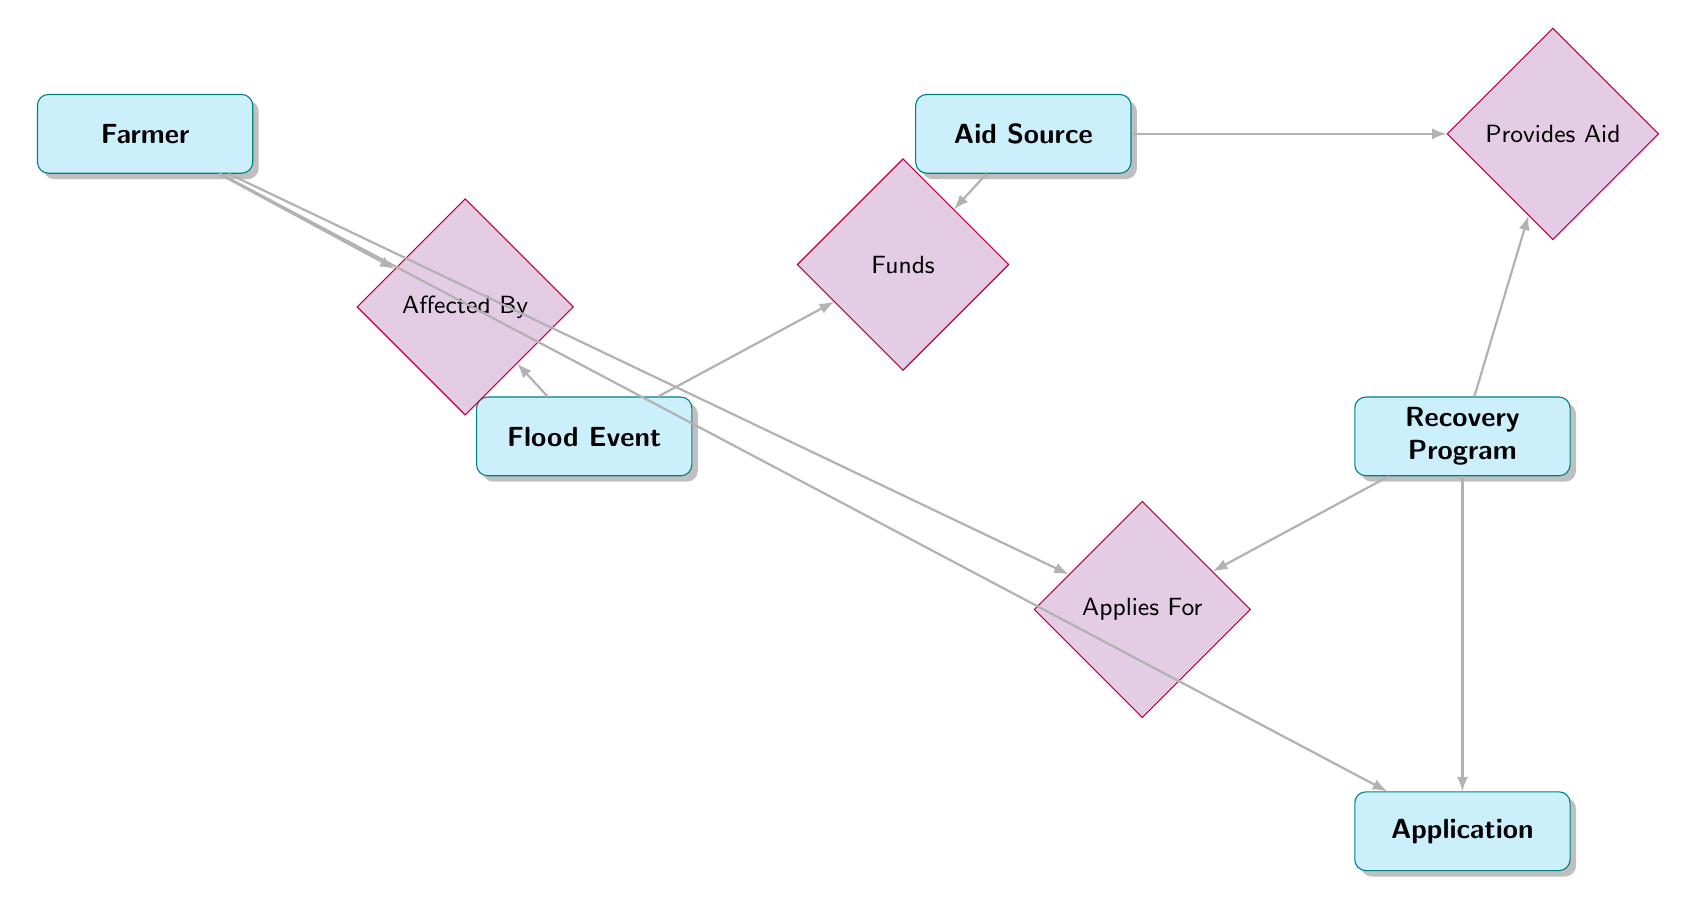What entities are present in the diagram? The diagram includes five entities: Farmer, Flood Event, Aid Source, Recovery Program, and Application.
Answer: Farmer, Flood Event, Aid Source, Recovery Program, Application How many relationships are shown in the diagram? There are four relationships in the diagram: Affected By, Provides Aid, Applies For, and Funds.
Answer: 4 What is the relationship between Farmer and Flood Event? The relationship is named Affected By, which indicates that Farmers are affected by Flood Events.
Answer: Affected By Which entity provides the aid for Recovery Programs? The Aid Source entity provides aid for Recovery Programs, as indicated by the Provides Aid relationship.
Answer: Aid Source How many applications can a Farmer submit for a Recovery Program? The diagram shows that a Farmer can submit multiple applications for different Recovery Programs, as there is an Applies For relationship connecting them.
Answer: Multiple What type of relationship exists between Aid Source and Flood Event? The relationship is named Funds, indicating a connection where Aid Sources fund Flood Events.
Answer: Funds Which entity has a direct link to Recovery Program applications? The Application entity has a direct link to the Recovery Program entity through the Applies For relationship.
Answer: Application What attribute links the Farmer to its application process? The attribute linking them is FarmerID, which is part of the Application entity that allows tracking of applications specific to each Farmer.
Answer: FarmerID 